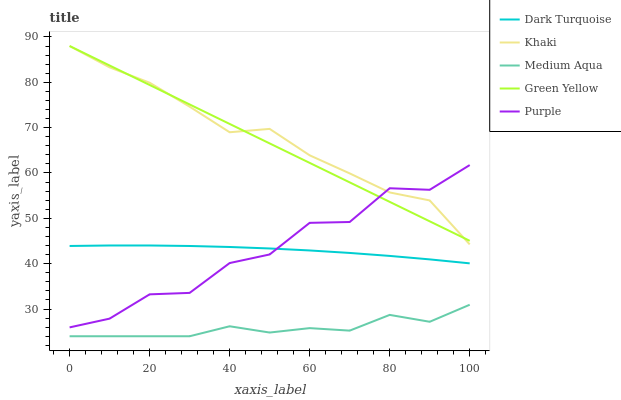Does Medium Aqua have the minimum area under the curve?
Answer yes or no. Yes. Does Khaki have the maximum area under the curve?
Answer yes or no. Yes. Does Dark Turquoise have the minimum area under the curve?
Answer yes or no. No. Does Dark Turquoise have the maximum area under the curve?
Answer yes or no. No. Is Green Yellow the smoothest?
Answer yes or no. Yes. Is Purple the roughest?
Answer yes or no. Yes. Is Dark Turquoise the smoothest?
Answer yes or no. No. Is Dark Turquoise the roughest?
Answer yes or no. No. Does Medium Aqua have the lowest value?
Answer yes or no. Yes. Does Dark Turquoise have the lowest value?
Answer yes or no. No. Does Khaki have the highest value?
Answer yes or no. Yes. Does Dark Turquoise have the highest value?
Answer yes or no. No. Is Medium Aqua less than Dark Turquoise?
Answer yes or no. Yes. Is Khaki greater than Medium Aqua?
Answer yes or no. Yes. Does Khaki intersect Purple?
Answer yes or no. Yes. Is Khaki less than Purple?
Answer yes or no. No. Is Khaki greater than Purple?
Answer yes or no. No. Does Medium Aqua intersect Dark Turquoise?
Answer yes or no. No. 